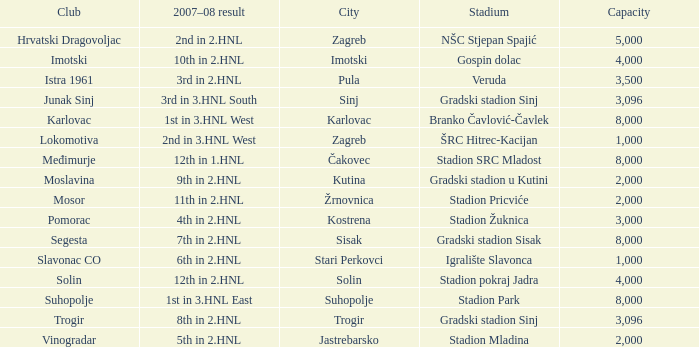What stadium has 9th in 2.hnl as the 2007-08 result? Gradski stadion u Kutini. 